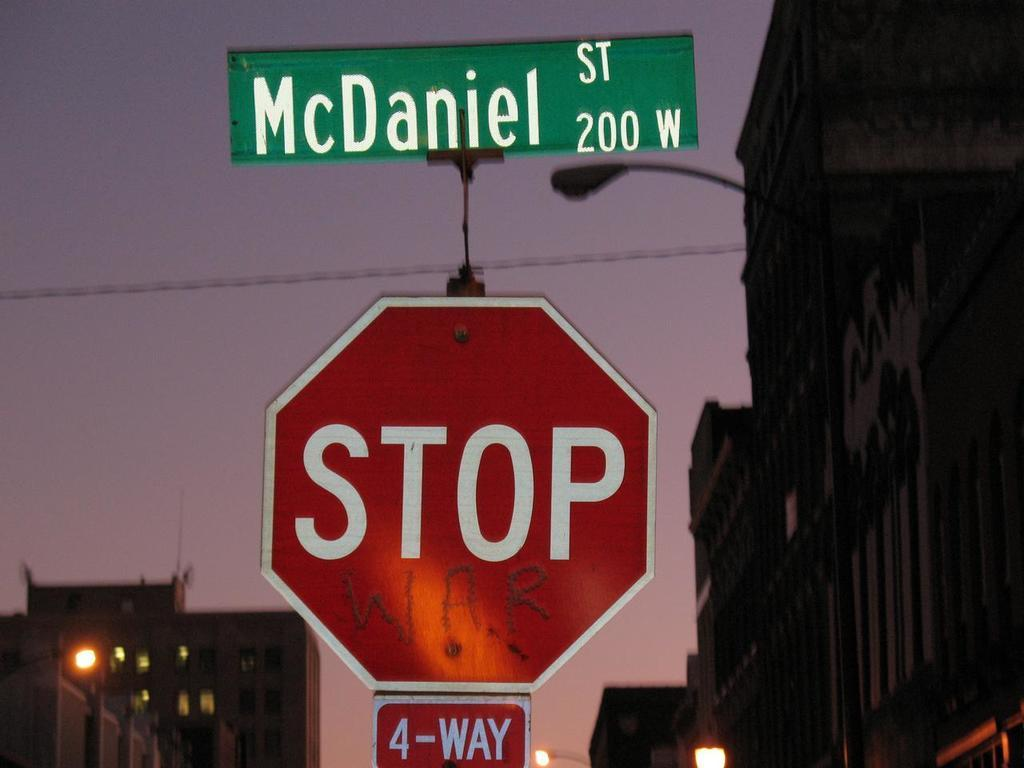<image>
Create a compact narrative representing the image presented. A green sign said McDaniel st and underneath is a stop sign. 